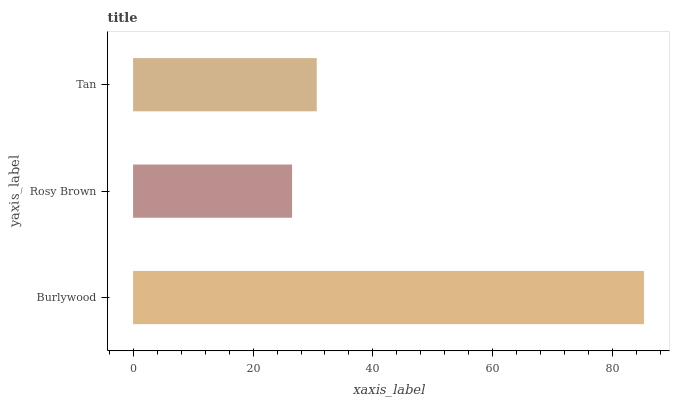Is Rosy Brown the minimum?
Answer yes or no. Yes. Is Burlywood the maximum?
Answer yes or no. Yes. Is Tan the minimum?
Answer yes or no. No. Is Tan the maximum?
Answer yes or no. No. Is Tan greater than Rosy Brown?
Answer yes or no. Yes. Is Rosy Brown less than Tan?
Answer yes or no. Yes. Is Rosy Brown greater than Tan?
Answer yes or no. No. Is Tan less than Rosy Brown?
Answer yes or no. No. Is Tan the high median?
Answer yes or no. Yes. Is Tan the low median?
Answer yes or no. Yes. Is Rosy Brown the high median?
Answer yes or no. No. Is Burlywood the low median?
Answer yes or no. No. 